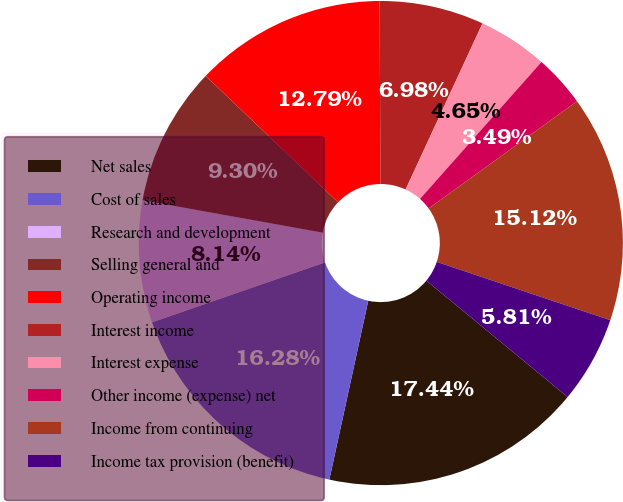Convert chart. <chart><loc_0><loc_0><loc_500><loc_500><pie_chart><fcel>Net sales<fcel>Cost of sales<fcel>Research and development<fcel>Selling general and<fcel>Operating income<fcel>Interest income<fcel>Interest expense<fcel>Other income (expense) net<fcel>Income from continuing<fcel>Income tax provision (benefit)<nl><fcel>17.44%<fcel>16.28%<fcel>8.14%<fcel>9.3%<fcel>12.79%<fcel>6.98%<fcel>4.65%<fcel>3.49%<fcel>15.12%<fcel>5.81%<nl></chart> 